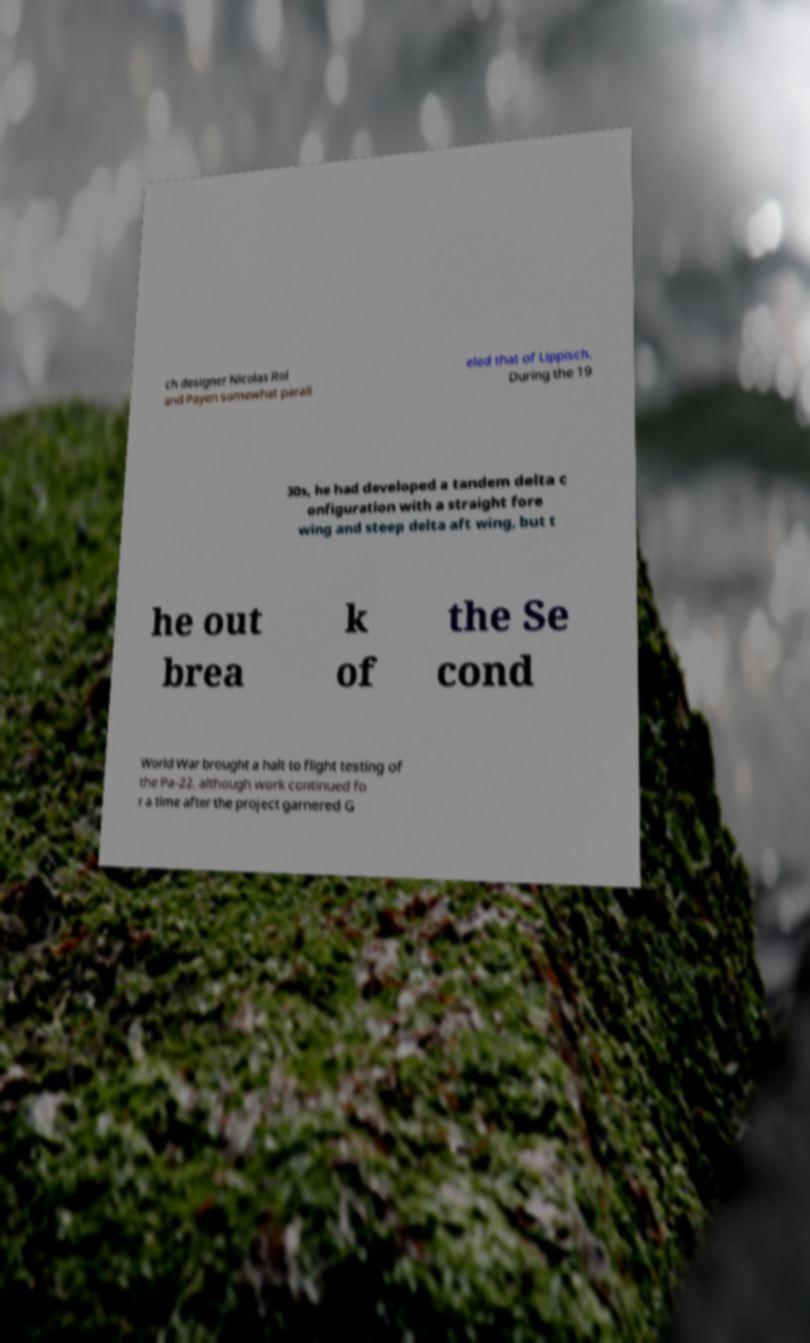Can you read and provide the text displayed in the image?This photo seems to have some interesting text. Can you extract and type it out for me? ch designer Nicolas Rol and Payen somewhat parall eled that of Lippisch. During the 19 30s, he had developed a tandem delta c onfiguration with a straight fore wing and steep delta aft wing, but t he out brea k of the Se cond World War brought a halt to flight testing of the Pa-22, although work continued fo r a time after the project garnered G 